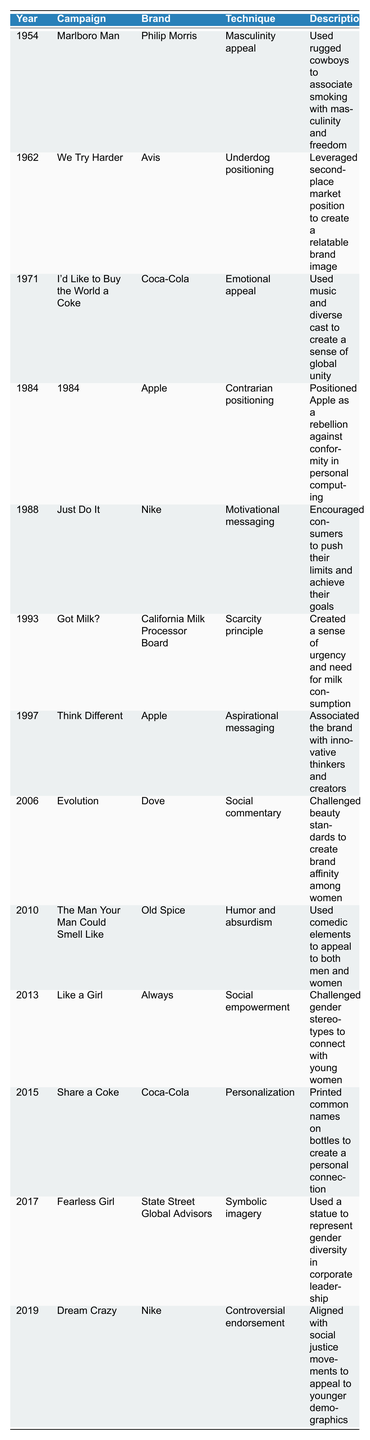What was the advertising technique used in the Marlboro Man campaign? The table states that the Marlboro Man campaign used the technique of masculinity appeal.
Answer: Masculinity appeal Which brand had a campaign focused on emotional appeal in 1971? According to the table, Coca-Cola had the "I'd Like to Buy the World a Coke" campaign in 1971, which focused on emotional appeal.
Answer: Coca-Cola Did Nike run the "Just Do It" campaign before 1990? The table shows that the "Just Do It" campaign was launched in 1988, which is before 1990.
Answer: Yes What are the years in which Apple launched its campaigns, and what were those campaigns? The table lists two campaigns by Apple: "1984" in 1984 and "Think Different" in 1997. These are the years and campaigns associated with Apple.
Answer: 1984: 1984, 1997: Think Different How many campaigns focused on social empowerment or social commentary? From the table, there are a total of two campaigns that focus on social empowerment or social commentary: "Evolution" by Dove in 2006 and "Like a Girl" by Always in 2013, so the count is 2.
Answer: 2 Which campaign utilized humor and absurdism, and in what year was it released? The table indicates that Old Spice's campaign "The Man Your Man Could Smell Like" used humor and absurdism, and it was released in 2010.
Answer: The Man Your Man Could Smell Like, 2010 Which brand employed the scarcity principle in its marketing campaign? The table specifies that the California Milk Processor Board employed the scarcity principle in the "Got Milk?" campaign in 1993.
Answer: California Milk Processor Board What was the technique used in the "Fearless Girl" campaign, and what year was it launched? The table states that the "Fearless Girl" campaign, launched in 2017, used symbolic imagery as its technique.
Answer: Symbolic imagery, 2017 In what context did Nike align its campaign "Dream Crazy" and which demographic was targeted? The table indicates that Nike's "Dream Crazy" campaign in 2019 aligned with social justice movements and targeted younger demographics.
Answer: Social justice movements, younger demographics 